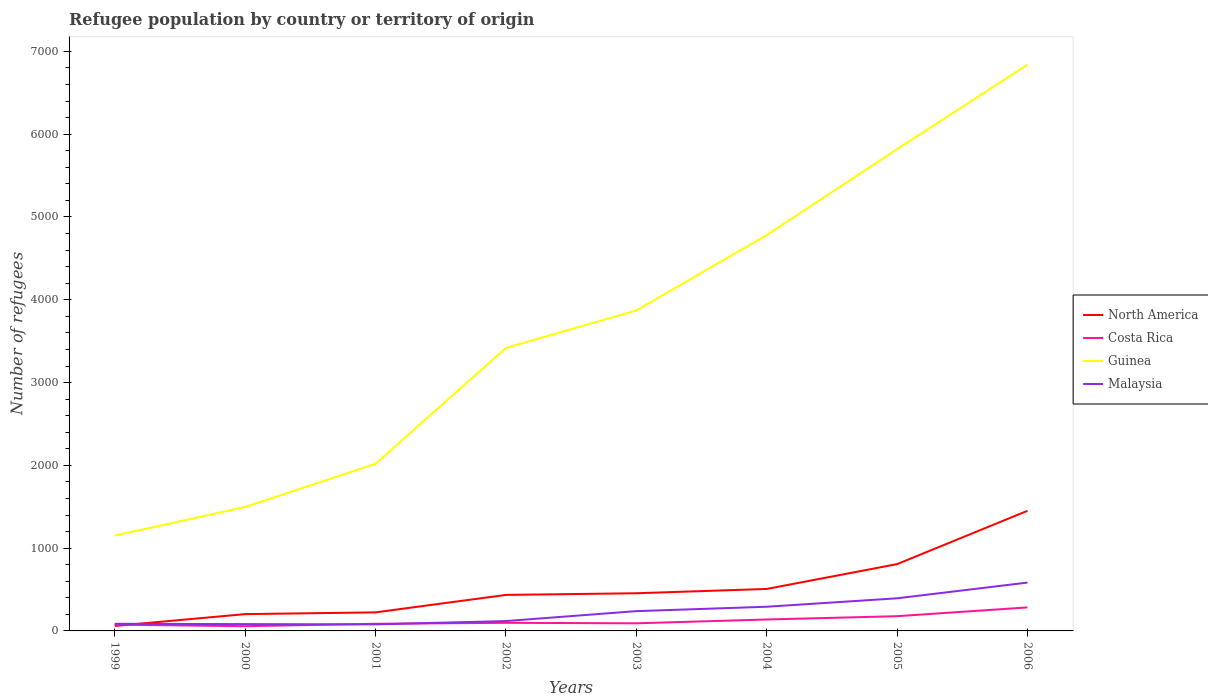How many different coloured lines are there?
Make the answer very short. 4. Does the line corresponding to Guinea intersect with the line corresponding to Costa Rica?
Provide a succinct answer. No. Across all years, what is the maximum number of refugees in Malaysia?
Provide a short and direct response. 79. In which year was the number of refugees in North America maximum?
Make the answer very short. 1999. What is the total number of refugees in Guinea in the graph?
Provide a succinct answer. -3285. What is the difference between the highest and the second highest number of refugees in Costa Rica?
Provide a short and direct response. 227. Is the number of refugees in Malaysia strictly greater than the number of refugees in Costa Rica over the years?
Provide a succinct answer. No. How many lines are there?
Provide a short and direct response. 4. How many years are there in the graph?
Make the answer very short. 8. What is the difference between two consecutive major ticks on the Y-axis?
Offer a terse response. 1000. Does the graph contain grids?
Offer a terse response. No. How are the legend labels stacked?
Make the answer very short. Vertical. What is the title of the graph?
Make the answer very short. Refugee population by country or territory of origin. Does "Monaco" appear as one of the legend labels in the graph?
Make the answer very short. No. What is the label or title of the X-axis?
Give a very brief answer. Years. What is the label or title of the Y-axis?
Offer a terse response. Number of refugees. What is the Number of refugees of North America in 1999?
Offer a terse response. 60. What is the Number of refugees in Costa Rica in 1999?
Ensure brevity in your answer.  76. What is the Number of refugees in Guinea in 1999?
Provide a succinct answer. 1151. What is the Number of refugees in Malaysia in 1999?
Ensure brevity in your answer.  86. What is the Number of refugees of North America in 2000?
Your response must be concise. 203. What is the Number of refugees of Costa Rica in 2000?
Make the answer very short. 57. What is the Number of refugees in Guinea in 2000?
Your answer should be very brief. 1497. What is the Number of refugees of North America in 2001?
Your answer should be very brief. 224. What is the Number of refugees of Costa Rica in 2001?
Provide a succinct answer. 86. What is the Number of refugees in Guinea in 2001?
Make the answer very short. 2019. What is the Number of refugees in Malaysia in 2001?
Ensure brevity in your answer.  79. What is the Number of refugees of North America in 2002?
Your response must be concise. 435. What is the Number of refugees in Guinea in 2002?
Your response must be concise. 3418. What is the Number of refugees of Malaysia in 2002?
Your answer should be very brief. 119. What is the Number of refugees of North America in 2003?
Your answer should be very brief. 455. What is the Number of refugees in Costa Rica in 2003?
Keep it short and to the point. 92. What is the Number of refugees of Guinea in 2003?
Make the answer very short. 3871. What is the Number of refugees in Malaysia in 2003?
Keep it short and to the point. 239. What is the Number of refugees in North America in 2004?
Your answer should be compact. 507. What is the Number of refugees in Costa Rica in 2004?
Your response must be concise. 138. What is the Number of refugees in Guinea in 2004?
Your answer should be very brief. 4782. What is the Number of refugees of Malaysia in 2004?
Your answer should be compact. 292. What is the Number of refugees of North America in 2005?
Make the answer very short. 807. What is the Number of refugees in Costa Rica in 2005?
Make the answer very short. 178. What is the Number of refugees of Guinea in 2005?
Offer a terse response. 5820. What is the Number of refugees of Malaysia in 2005?
Give a very brief answer. 394. What is the Number of refugees in North America in 2006?
Keep it short and to the point. 1451. What is the Number of refugees of Costa Rica in 2006?
Offer a very short reply. 284. What is the Number of refugees in Guinea in 2006?
Keep it short and to the point. 6840. What is the Number of refugees of Malaysia in 2006?
Give a very brief answer. 584. Across all years, what is the maximum Number of refugees in North America?
Offer a very short reply. 1451. Across all years, what is the maximum Number of refugees of Costa Rica?
Keep it short and to the point. 284. Across all years, what is the maximum Number of refugees in Guinea?
Provide a succinct answer. 6840. Across all years, what is the maximum Number of refugees of Malaysia?
Ensure brevity in your answer.  584. Across all years, what is the minimum Number of refugees in North America?
Your answer should be very brief. 60. Across all years, what is the minimum Number of refugees in Costa Rica?
Your answer should be compact. 57. Across all years, what is the minimum Number of refugees in Guinea?
Offer a very short reply. 1151. Across all years, what is the minimum Number of refugees of Malaysia?
Offer a terse response. 79. What is the total Number of refugees of North America in the graph?
Your response must be concise. 4142. What is the total Number of refugees in Costa Rica in the graph?
Your answer should be compact. 1009. What is the total Number of refugees of Guinea in the graph?
Your answer should be compact. 2.94e+04. What is the total Number of refugees of Malaysia in the graph?
Provide a succinct answer. 1875. What is the difference between the Number of refugees in North America in 1999 and that in 2000?
Your answer should be very brief. -143. What is the difference between the Number of refugees in Costa Rica in 1999 and that in 2000?
Make the answer very short. 19. What is the difference between the Number of refugees in Guinea in 1999 and that in 2000?
Provide a short and direct response. -346. What is the difference between the Number of refugees of Malaysia in 1999 and that in 2000?
Ensure brevity in your answer.  4. What is the difference between the Number of refugees in North America in 1999 and that in 2001?
Keep it short and to the point. -164. What is the difference between the Number of refugees in Costa Rica in 1999 and that in 2001?
Your answer should be compact. -10. What is the difference between the Number of refugees of Guinea in 1999 and that in 2001?
Your response must be concise. -868. What is the difference between the Number of refugees of Malaysia in 1999 and that in 2001?
Ensure brevity in your answer.  7. What is the difference between the Number of refugees of North America in 1999 and that in 2002?
Provide a short and direct response. -375. What is the difference between the Number of refugees in Guinea in 1999 and that in 2002?
Your response must be concise. -2267. What is the difference between the Number of refugees in Malaysia in 1999 and that in 2002?
Make the answer very short. -33. What is the difference between the Number of refugees in North America in 1999 and that in 2003?
Your answer should be compact. -395. What is the difference between the Number of refugees in Guinea in 1999 and that in 2003?
Give a very brief answer. -2720. What is the difference between the Number of refugees of Malaysia in 1999 and that in 2003?
Your response must be concise. -153. What is the difference between the Number of refugees in North America in 1999 and that in 2004?
Your answer should be very brief. -447. What is the difference between the Number of refugees in Costa Rica in 1999 and that in 2004?
Your answer should be compact. -62. What is the difference between the Number of refugees of Guinea in 1999 and that in 2004?
Provide a short and direct response. -3631. What is the difference between the Number of refugees in Malaysia in 1999 and that in 2004?
Your response must be concise. -206. What is the difference between the Number of refugees in North America in 1999 and that in 2005?
Provide a short and direct response. -747. What is the difference between the Number of refugees of Costa Rica in 1999 and that in 2005?
Give a very brief answer. -102. What is the difference between the Number of refugees in Guinea in 1999 and that in 2005?
Offer a terse response. -4669. What is the difference between the Number of refugees in Malaysia in 1999 and that in 2005?
Offer a very short reply. -308. What is the difference between the Number of refugees of North America in 1999 and that in 2006?
Give a very brief answer. -1391. What is the difference between the Number of refugees of Costa Rica in 1999 and that in 2006?
Your answer should be very brief. -208. What is the difference between the Number of refugees in Guinea in 1999 and that in 2006?
Offer a terse response. -5689. What is the difference between the Number of refugees in Malaysia in 1999 and that in 2006?
Offer a terse response. -498. What is the difference between the Number of refugees in Guinea in 2000 and that in 2001?
Ensure brevity in your answer.  -522. What is the difference between the Number of refugees of Malaysia in 2000 and that in 2001?
Offer a very short reply. 3. What is the difference between the Number of refugees in North America in 2000 and that in 2002?
Ensure brevity in your answer.  -232. What is the difference between the Number of refugees in Costa Rica in 2000 and that in 2002?
Your answer should be very brief. -41. What is the difference between the Number of refugees in Guinea in 2000 and that in 2002?
Provide a succinct answer. -1921. What is the difference between the Number of refugees of Malaysia in 2000 and that in 2002?
Offer a terse response. -37. What is the difference between the Number of refugees in North America in 2000 and that in 2003?
Your answer should be very brief. -252. What is the difference between the Number of refugees in Costa Rica in 2000 and that in 2003?
Your response must be concise. -35. What is the difference between the Number of refugees in Guinea in 2000 and that in 2003?
Provide a succinct answer. -2374. What is the difference between the Number of refugees in Malaysia in 2000 and that in 2003?
Give a very brief answer. -157. What is the difference between the Number of refugees of North America in 2000 and that in 2004?
Your answer should be compact. -304. What is the difference between the Number of refugees in Costa Rica in 2000 and that in 2004?
Provide a succinct answer. -81. What is the difference between the Number of refugees of Guinea in 2000 and that in 2004?
Keep it short and to the point. -3285. What is the difference between the Number of refugees in Malaysia in 2000 and that in 2004?
Provide a succinct answer. -210. What is the difference between the Number of refugees of North America in 2000 and that in 2005?
Provide a succinct answer. -604. What is the difference between the Number of refugees in Costa Rica in 2000 and that in 2005?
Make the answer very short. -121. What is the difference between the Number of refugees in Guinea in 2000 and that in 2005?
Your response must be concise. -4323. What is the difference between the Number of refugees in Malaysia in 2000 and that in 2005?
Provide a succinct answer. -312. What is the difference between the Number of refugees in North America in 2000 and that in 2006?
Your response must be concise. -1248. What is the difference between the Number of refugees of Costa Rica in 2000 and that in 2006?
Your answer should be very brief. -227. What is the difference between the Number of refugees in Guinea in 2000 and that in 2006?
Make the answer very short. -5343. What is the difference between the Number of refugees of Malaysia in 2000 and that in 2006?
Your answer should be compact. -502. What is the difference between the Number of refugees in North America in 2001 and that in 2002?
Give a very brief answer. -211. What is the difference between the Number of refugees of Guinea in 2001 and that in 2002?
Your answer should be very brief. -1399. What is the difference between the Number of refugees of North America in 2001 and that in 2003?
Give a very brief answer. -231. What is the difference between the Number of refugees in Guinea in 2001 and that in 2003?
Ensure brevity in your answer.  -1852. What is the difference between the Number of refugees in Malaysia in 2001 and that in 2003?
Keep it short and to the point. -160. What is the difference between the Number of refugees in North America in 2001 and that in 2004?
Offer a terse response. -283. What is the difference between the Number of refugees of Costa Rica in 2001 and that in 2004?
Keep it short and to the point. -52. What is the difference between the Number of refugees in Guinea in 2001 and that in 2004?
Give a very brief answer. -2763. What is the difference between the Number of refugees in Malaysia in 2001 and that in 2004?
Your response must be concise. -213. What is the difference between the Number of refugees of North America in 2001 and that in 2005?
Your response must be concise. -583. What is the difference between the Number of refugees of Costa Rica in 2001 and that in 2005?
Offer a very short reply. -92. What is the difference between the Number of refugees in Guinea in 2001 and that in 2005?
Your answer should be compact. -3801. What is the difference between the Number of refugees of Malaysia in 2001 and that in 2005?
Ensure brevity in your answer.  -315. What is the difference between the Number of refugees of North America in 2001 and that in 2006?
Provide a succinct answer. -1227. What is the difference between the Number of refugees in Costa Rica in 2001 and that in 2006?
Give a very brief answer. -198. What is the difference between the Number of refugees of Guinea in 2001 and that in 2006?
Provide a short and direct response. -4821. What is the difference between the Number of refugees in Malaysia in 2001 and that in 2006?
Your response must be concise. -505. What is the difference between the Number of refugees in Guinea in 2002 and that in 2003?
Provide a short and direct response. -453. What is the difference between the Number of refugees of Malaysia in 2002 and that in 2003?
Your answer should be compact. -120. What is the difference between the Number of refugees of North America in 2002 and that in 2004?
Give a very brief answer. -72. What is the difference between the Number of refugees in Costa Rica in 2002 and that in 2004?
Offer a very short reply. -40. What is the difference between the Number of refugees of Guinea in 2002 and that in 2004?
Give a very brief answer. -1364. What is the difference between the Number of refugees in Malaysia in 2002 and that in 2004?
Provide a succinct answer. -173. What is the difference between the Number of refugees in North America in 2002 and that in 2005?
Provide a succinct answer. -372. What is the difference between the Number of refugees of Costa Rica in 2002 and that in 2005?
Provide a succinct answer. -80. What is the difference between the Number of refugees of Guinea in 2002 and that in 2005?
Offer a very short reply. -2402. What is the difference between the Number of refugees of Malaysia in 2002 and that in 2005?
Give a very brief answer. -275. What is the difference between the Number of refugees in North America in 2002 and that in 2006?
Offer a very short reply. -1016. What is the difference between the Number of refugees in Costa Rica in 2002 and that in 2006?
Offer a terse response. -186. What is the difference between the Number of refugees in Guinea in 2002 and that in 2006?
Offer a terse response. -3422. What is the difference between the Number of refugees in Malaysia in 2002 and that in 2006?
Your answer should be very brief. -465. What is the difference between the Number of refugees in North America in 2003 and that in 2004?
Provide a succinct answer. -52. What is the difference between the Number of refugees of Costa Rica in 2003 and that in 2004?
Make the answer very short. -46. What is the difference between the Number of refugees of Guinea in 2003 and that in 2004?
Offer a very short reply. -911. What is the difference between the Number of refugees in Malaysia in 2003 and that in 2004?
Ensure brevity in your answer.  -53. What is the difference between the Number of refugees in North America in 2003 and that in 2005?
Ensure brevity in your answer.  -352. What is the difference between the Number of refugees in Costa Rica in 2003 and that in 2005?
Provide a short and direct response. -86. What is the difference between the Number of refugees in Guinea in 2003 and that in 2005?
Your answer should be compact. -1949. What is the difference between the Number of refugees in Malaysia in 2003 and that in 2005?
Provide a succinct answer. -155. What is the difference between the Number of refugees in North America in 2003 and that in 2006?
Make the answer very short. -996. What is the difference between the Number of refugees of Costa Rica in 2003 and that in 2006?
Keep it short and to the point. -192. What is the difference between the Number of refugees of Guinea in 2003 and that in 2006?
Keep it short and to the point. -2969. What is the difference between the Number of refugees in Malaysia in 2003 and that in 2006?
Give a very brief answer. -345. What is the difference between the Number of refugees of North America in 2004 and that in 2005?
Ensure brevity in your answer.  -300. What is the difference between the Number of refugees of Costa Rica in 2004 and that in 2005?
Ensure brevity in your answer.  -40. What is the difference between the Number of refugees of Guinea in 2004 and that in 2005?
Keep it short and to the point. -1038. What is the difference between the Number of refugees of Malaysia in 2004 and that in 2005?
Provide a succinct answer. -102. What is the difference between the Number of refugees in North America in 2004 and that in 2006?
Provide a short and direct response. -944. What is the difference between the Number of refugees of Costa Rica in 2004 and that in 2006?
Ensure brevity in your answer.  -146. What is the difference between the Number of refugees of Guinea in 2004 and that in 2006?
Keep it short and to the point. -2058. What is the difference between the Number of refugees of Malaysia in 2004 and that in 2006?
Your answer should be compact. -292. What is the difference between the Number of refugees of North America in 2005 and that in 2006?
Your answer should be compact. -644. What is the difference between the Number of refugees of Costa Rica in 2005 and that in 2006?
Keep it short and to the point. -106. What is the difference between the Number of refugees of Guinea in 2005 and that in 2006?
Give a very brief answer. -1020. What is the difference between the Number of refugees in Malaysia in 2005 and that in 2006?
Your answer should be compact. -190. What is the difference between the Number of refugees of North America in 1999 and the Number of refugees of Costa Rica in 2000?
Your answer should be very brief. 3. What is the difference between the Number of refugees of North America in 1999 and the Number of refugees of Guinea in 2000?
Give a very brief answer. -1437. What is the difference between the Number of refugees in Costa Rica in 1999 and the Number of refugees in Guinea in 2000?
Your answer should be very brief. -1421. What is the difference between the Number of refugees in Guinea in 1999 and the Number of refugees in Malaysia in 2000?
Your answer should be compact. 1069. What is the difference between the Number of refugees of North America in 1999 and the Number of refugees of Costa Rica in 2001?
Your response must be concise. -26. What is the difference between the Number of refugees in North America in 1999 and the Number of refugees in Guinea in 2001?
Provide a short and direct response. -1959. What is the difference between the Number of refugees in North America in 1999 and the Number of refugees in Malaysia in 2001?
Offer a terse response. -19. What is the difference between the Number of refugees in Costa Rica in 1999 and the Number of refugees in Guinea in 2001?
Keep it short and to the point. -1943. What is the difference between the Number of refugees of Guinea in 1999 and the Number of refugees of Malaysia in 2001?
Offer a terse response. 1072. What is the difference between the Number of refugees of North America in 1999 and the Number of refugees of Costa Rica in 2002?
Ensure brevity in your answer.  -38. What is the difference between the Number of refugees of North America in 1999 and the Number of refugees of Guinea in 2002?
Your answer should be compact. -3358. What is the difference between the Number of refugees in North America in 1999 and the Number of refugees in Malaysia in 2002?
Make the answer very short. -59. What is the difference between the Number of refugees of Costa Rica in 1999 and the Number of refugees of Guinea in 2002?
Ensure brevity in your answer.  -3342. What is the difference between the Number of refugees in Costa Rica in 1999 and the Number of refugees in Malaysia in 2002?
Provide a succinct answer. -43. What is the difference between the Number of refugees of Guinea in 1999 and the Number of refugees of Malaysia in 2002?
Give a very brief answer. 1032. What is the difference between the Number of refugees in North America in 1999 and the Number of refugees in Costa Rica in 2003?
Your response must be concise. -32. What is the difference between the Number of refugees in North America in 1999 and the Number of refugees in Guinea in 2003?
Keep it short and to the point. -3811. What is the difference between the Number of refugees of North America in 1999 and the Number of refugees of Malaysia in 2003?
Your answer should be very brief. -179. What is the difference between the Number of refugees in Costa Rica in 1999 and the Number of refugees in Guinea in 2003?
Provide a succinct answer. -3795. What is the difference between the Number of refugees of Costa Rica in 1999 and the Number of refugees of Malaysia in 2003?
Ensure brevity in your answer.  -163. What is the difference between the Number of refugees in Guinea in 1999 and the Number of refugees in Malaysia in 2003?
Ensure brevity in your answer.  912. What is the difference between the Number of refugees of North America in 1999 and the Number of refugees of Costa Rica in 2004?
Provide a short and direct response. -78. What is the difference between the Number of refugees of North America in 1999 and the Number of refugees of Guinea in 2004?
Your answer should be compact. -4722. What is the difference between the Number of refugees of North America in 1999 and the Number of refugees of Malaysia in 2004?
Offer a very short reply. -232. What is the difference between the Number of refugees in Costa Rica in 1999 and the Number of refugees in Guinea in 2004?
Make the answer very short. -4706. What is the difference between the Number of refugees of Costa Rica in 1999 and the Number of refugees of Malaysia in 2004?
Your answer should be compact. -216. What is the difference between the Number of refugees in Guinea in 1999 and the Number of refugees in Malaysia in 2004?
Your answer should be very brief. 859. What is the difference between the Number of refugees of North America in 1999 and the Number of refugees of Costa Rica in 2005?
Your answer should be very brief. -118. What is the difference between the Number of refugees in North America in 1999 and the Number of refugees in Guinea in 2005?
Provide a short and direct response. -5760. What is the difference between the Number of refugees in North America in 1999 and the Number of refugees in Malaysia in 2005?
Make the answer very short. -334. What is the difference between the Number of refugees in Costa Rica in 1999 and the Number of refugees in Guinea in 2005?
Provide a succinct answer. -5744. What is the difference between the Number of refugees of Costa Rica in 1999 and the Number of refugees of Malaysia in 2005?
Keep it short and to the point. -318. What is the difference between the Number of refugees in Guinea in 1999 and the Number of refugees in Malaysia in 2005?
Provide a succinct answer. 757. What is the difference between the Number of refugees of North America in 1999 and the Number of refugees of Costa Rica in 2006?
Your response must be concise. -224. What is the difference between the Number of refugees of North America in 1999 and the Number of refugees of Guinea in 2006?
Offer a very short reply. -6780. What is the difference between the Number of refugees of North America in 1999 and the Number of refugees of Malaysia in 2006?
Ensure brevity in your answer.  -524. What is the difference between the Number of refugees of Costa Rica in 1999 and the Number of refugees of Guinea in 2006?
Provide a short and direct response. -6764. What is the difference between the Number of refugees in Costa Rica in 1999 and the Number of refugees in Malaysia in 2006?
Provide a succinct answer. -508. What is the difference between the Number of refugees in Guinea in 1999 and the Number of refugees in Malaysia in 2006?
Offer a very short reply. 567. What is the difference between the Number of refugees in North America in 2000 and the Number of refugees in Costa Rica in 2001?
Your answer should be compact. 117. What is the difference between the Number of refugees of North America in 2000 and the Number of refugees of Guinea in 2001?
Ensure brevity in your answer.  -1816. What is the difference between the Number of refugees of North America in 2000 and the Number of refugees of Malaysia in 2001?
Your answer should be compact. 124. What is the difference between the Number of refugees of Costa Rica in 2000 and the Number of refugees of Guinea in 2001?
Give a very brief answer. -1962. What is the difference between the Number of refugees in Guinea in 2000 and the Number of refugees in Malaysia in 2001?
Your response must be concise. 1418. What is the difference between the Number of refugees in North America in 2000 and the Number of refugees in Costa Rica in 2002?
Offer a terse response. 105. What is the difference between the Number of refugees of North America in 2000 and the Number of refugees of Guinea in 2002?
Your response must be concise. -3215. What is the difference between the Number of refugees of North America in 2000 and the Number of refugees of Malaysia in 2002?
Offer a terse response. 84. What is the difference between the Number of refugees of Costa Rica in 2000 and the Number of refugees of Guinea in 2002?
Your response must be concise. -3361. What is the difference between the Number of refugees in Costa Rica in 2000 and the Number of refugees in Malaysia in 2002?
Offer a very short reply. -62. What is the difference between the Number of refugees in Guinea in 2000 and the Number of refugees in Malaysia in 2002?
Offer a very short reply. 1378. What is the difference between the Number of refugees of North America in 2000 and the Number of refugees of Costa Rica in 2003?
Your answer should be very brief. 111. What is the difference between the Number of refugees in North America in 2000 and the Number of refugees in Guinea in 2003?
Provide a succinct answer. -3668. What is the difference between the Number of refugees of North America in 2000 and the Number of refugees of Malaysia in 2003?
Provide a succinct answer. -36. What is the difference between the Number of refugees in Costa Rica in 2000 and the Number of refugees in Guinea in 2003?
Your answer should be compact. -3814. What is the difference between the Number of refugees of Costa Rica in 2000 and the Number of refugees of Malaysia in 2003?
Your answer should be very brief. -182. What is the difference between the Number of refugees of Guinea in 2000 and the Number of refugees of Malaysia in 2003?
Your response must be concise. 1258. What is the difference between the Number of refugees of North America in 2000 and the Number of refugees of Guinea in 2004?
Provide a short and direct response. -4579. What is the difference between the Number of refugees in North America in 2000 and the Number of refugees in Malaysia in 2004?
Your answer should be compact. -89. What is the difference between the Number of refugees of Costa Rica in 2000 and the Number of refugees of Guinea in 2004?
Your response must be concise. -4725. What is the difference between the Number of refugees in Costa Rica in 2000 and the Number of refugees in Malaysia in 2004?
Keep it short and to the point. -235. What is the difference between the Number of refugees of Guinea in 2000 and the Number of refugees of Malaysia in 2004?
Your answer should be compact. 1205. What is the difference between the Number of refugees in North America in 2000 and the Number of refugees in Guinea in 2005?
Your response must be concise. -5617. What is the difference between the Number of refugees of North America in 2000 and the Number of refugees of Malaysia in 2005?
Offer a terse response. -191. What is the difference between the Number of refugees in Costa Rica in 2000 and the Number of refugees in Guinea in 2005?
Your answer should be compact. -5763. What is the difference between the Number of refugees in Costa Rica in 2000 and the Number of refugees in Malaysia in 2005?
Provide a succinct answer. -337. What is the difference between the Number of refugees in Guinea in 2000 and the Number of refugees in Malaysia in 2005?
Provide a short and direct response. 1103. What is the difference between the Number of refugees of North America in 2000 and the Number of refugees of Costa Rica in 2006?
Your answer should be compact. -81. What is the difference between the Number of refugees in North America in 2000 and the Number of refugees in Guinea in 2006?
Your answer should be compact. -6637. What is the difference between the Number of refugees in North America in 2000 and the Number of refugees in Malaysia in 2006?
Provide a succinct answer. -381. What is the difference between the Number of refugees in Costa Rica in 2000 and the Number of refugees in Guinea in 2006?
Your answer should be compact. -6783. What is the difference between the Number of refugees of Costa Rica in 2000 and the Number of refugees of Malaysia in 2006?
Provide a short and direct response. -527. What is the difference between the Number of refugees of Guinea in 2000 and the Number of refugees of Malaysia in 2006?
Provide a succinct answer. 913. What is the difference between the Number of refugees in North America in 2001 and the Number of refugees in Costa Rica in 2002?
Make the answer very short. 126. What is the difference between the Number of refugees in North America in 2001 and the Number of refugees in Guinea in 2002?
Your response must be concise. -3194. What is the difference between the Number of refugees of North America in 2001 and the Number of refugees of Malaysia in 2002?
Keep it short and to the point. 105. What is the difference between the Number of refugees in Costa Rica in 2001 and the Number of refugees in Guinea in 2002?
Offer a very short reply. -3332. What is the difference between the Number of refugees of Costa Rica in 2001 and the Number of refugees of Malaysia in 2002?
Make the answer very short. -33. What is the difference between the Number of refugees of Guinea in 2001 and the Number of refugees of Malaysia in 2002?
Keep it short and to the point. 1900. What is the difference between the Number of refugees of North America in 2001 and the Number of refugees of Costa Rica in 2003?
Your answer should be very brief. 132. What is the difference between the Number of refugees in North America in 2001 and the Number of refugees in Guinea in 2003?
Provide a succinct answer. -3647. What is the difference between the Number of refugees in North America in 2001 and the Number of refugees in Malaysia in 2003?
Keep it short and to the point. -15. What is the difference between the Number of refugees in Costa Rica in 2001 and the Number of refugees in Guinea in 2003?
Provide a short and direct response. -3785. What is the difference between the Number of refugees of Costa Rica in 2001 and the Number of refugees of Malaysia in 2003?
Provide a succinct answer. -153. What is the difference between the Number of refugees in Guinea in 2001 and the Number of refugees in Malaysia in 2003?
Give a very brief answer. 1780. What is the difference between the Number of refugees of North America in 2001 and the Number of refugees of Guinea in 2004?
Offer a terse response. -4558. What is the difference between the Number of refugees of North America in 2001 and the Number of refugees of Malaysia in 2004?
Provide a succinct answer. -68. What is the difference between the Number of refugees of Costa Rica in 2001 and the Number of refugees of Guinea in 2004?
Offer a terse response. -4696. What is the difference between the Number of refugees in Costa Rica in 2001 and the Number of refugees in Malaysia in 2004?
Make the answer very short. -206. What is the difference between the Number of refugees of Guinea in 2001 and the Number of refugees of Malaysia in 2004?
Give a very brief answer. 1727. What is the difference between the Number of refugees in North America in 2001 and the Number of refugees in Costa Rica in 2005?
Your answer should be compact. 46. What is the difference between the Number of refugees in North America in 2001 and the Number of refugees in Guinea in 2005?
Ensure brevity in your answer.  -5596. What is the difference between the Number of refugees in North America in 2001 and the Number of refugees in Malaysia in 2005?
Keep it short and to the point. -170. What is the difference between the Number of refugees of Costa Rica in 2001 and the Number of refugees of Guinea in 2005?
Your response must be concise. -5734. What is the difference between the Number of refugees in Costa Rica in 2001 and the Number of refugees in Malaysia in 2005?
Your response must be concise. -308. What is the difference between the Number of refugees in Guinea in 2001 and the Number of refugees in Malaysia in 2005?
Give a very brief answer. 1625. What is the difference between the Number of refugees in North America in 2001 and the Number of refugees in Costa Rica in 2006?
Your answer should be compact. -60. What is the difference between the Number of refugees in North America in 2001 and the Number of refugees in Guinea in 2006?
Provide a succinct answer. -6616. What is the difference between the Number of refugees of North America in 2001 and the Number of refugees of Malaysia in 2006?
Your answer should be very brief. -360. What is the difference between the Number of refugees in Costa Rica in 2001 and the Number of refugees in Guinea in 2006?
Provide a succinct answer. -6754. What is the difference between the Number of refugees in Costa Rica in 2001 and the Number of refugees in Malaysia in 2006?
Make the answer very short. -498. What is the difference between the Number of refugees of Guinea in 2001 and the Number of refugees of Malaysia in 2006?
Offer a very short reply. 1435. What is the difference between the Number of refugees of North America in 2002 and the Number of refugees of Costa Rica in 2003?
Your response must be concise. 343. What is the difference between the Number of refugees in North America in 2002 and the Number of refugees in Guinea in 2003?
Your answer should be very brief. -3436. What is the difference between the Number of refugees in North America in 2002 and the Number of refugees in Malaysia in 2003?
Your answer should be very brief. 196. What is the difference between the Number of refugees in Costa Rica in 2002 and the Number of refugees in Guinea in 2003?
Provide a short and direct response. -3773. What is the difference between the Number of refugees of Costa Rica in 2002 and the Number of refugees of Malaysia in 2003?
Your answer should be very brief. -141. What is the difference between the Number of refugees of Guinea in 2002 and the Number of refugees of Malaysia in 2003?
Make the answer very short. 3179. What is the difference between the Number of refugees of North America in 2002 and the Number of refugees of Costa Rica in 2004?
Ensure brevity in your answer.  297. What is the difference between the Number of refugees in North America in 2002 and the Number of refugees in Guinea in 2004?
Your answer should be very brief. -4347. What is the difference between the Number of refugees in North America in 2002 and the Number of refugees in Malaysia in 2004?
Your response must be concise. 143. What is the difference between the Number of refugees in Costa Rica in 2002 and the Number of refugees in Guinea in 2004?
Provide a succinct answer. -4684. What is the difference between the Number of refugees in Costa Rica in 2002 and the Number of refugees in Malaysia in 2004?
Offer a terse response. -194. What is the difference between the Number of refugees of Guinea in 2002 and the Number of refugees of Malaysia in 2004?
Your response must be concise. 3126. What is the difference between the Number of refugees in North America in 2002 and the Number of refugees in Costa Rica in 2005?
Your answer should be compact. 257. What is the difference between the Number of refugees in North America in 2002 and the Number of refugees in Guinea in 2005?
Offer a very short reply. -5385. What is the difference between the Number of refugees in North America in 2002 and the Number of refugees in Malaysia in 2005?
Provide a short and direct response. 41. What is the difference between the Number of refugees in Costa Rica in 2002 and the Number of refugees in Guinea in 2005?
Offer a very short reply. -5722. What is the difference between the Number of refugees of Costa Rica in 2002 and the Number of refugees of Malaysia in 2005?
Make the answer very short. -296. What is the difference between the Number of refugees of Guinea in 2002 and the Number of refugees of Malaysia in 2005?
Ensure brevity in your answer.  3024. What is the difference between the Number of refugees of North America in 2002 and the Number of refugees of Costa Rica in 2006?
Provide a short and direct response. 151. What is the difference between the Number of refugees of North America in 2002 and the Number of refugees of Guinea in 2006?
Your answer should be very brief. -6405. What is the difference between the Number of refugees in North America in 2002 and the Number of refugees in Malaysia in 2006?
Keep it short and to the point. -149. What is the difference between the Number of refugees in Costa Rica in 2002 and the Number of refugees in Guinea in 2006?
Offer a terse response. -6742. What is the difference between the Number of refugees in Costa Rica in 2002 and the Number of refugees in Malaysia in 2006?
Give a very brief answer. -486. What is the difference between the Number of refugees in Guinea in 2002 and the Number of refugees in Malaysia in 2006?
Ensure brevity in your answer.  2834. What is the difference between the Number of refugees of North America in 2003 and the Number of refugees of Costa Rica in 2004?
Your answer should be compact. 317. What is the difference between the Number of refugees in North America in 2003 and the Number of refugees in Guinea in 2004?
Keep it short and to the point. -4327. What is the difference between the Number of refugees in North America in 2003 and the Number of refugees in Malaysia in 2004?
Offer a very short reply. 163. What is the difference between the Number of refugees of Costa Rica in 2003 and the Number of refugees of Guinea in 2004?
Make the answer very short. -4690. What is the difference between the Number of refugees in Costa Rica in 2003 and the Number of refugees in Malaysia in 2004?
Your answer should be very brief. -200. What is the difference between the Number of refugees of Guinea in 2003 and the Number of refugees of Malaysia in 2004?
Give a very brief answer. 3579. What is the difference between the Number of refugees of North America in 2003 and the Number of refugees of Costa Rica in 2005?
Provide a short and direct response. 277. What is the difference between the Number of refugees of North America in 2003 and the Number of refugees of Guinea in 2005?
Keep it short and to the point. -5365. What is the difference between the Number of refugees in North America in 2003 and the Number of refugees in Malaysia in 2005?
Your response must be concise. 61. What is the difference between the Number of refugees in Costa Rica in 2003 and the Number of refugees in Guinea in 2005?
Your answer should be very brief. -5728. What is the difference between the Number of refugees of Costa Rica in 2003 and the Number of refugees of Malaysia in 2005?
Offer a very short reply. -302. What is the difference between the Number of refugees in Guinea in 2003 and the Number of refugees in Malaysia in 2005?
Keep it short and to the point. 3477. What is the difference between the Number of refugees in North America in 2003 and the Number of refugees in Costa Rica in 2006?
Your response must be concise. 171. What is the difference between the Number of refugees of North America in 2003 and the Number of refugees of Guinea in 2006?
Ensure brevity in your answer.  -6385. What is the difference between the Number of refugees of North America in 2003 and the Number of refugees of Malaysia in 2006?
Provide a short and direct response. -129. What is the difference between the Number of refugees of Costa Rica in 2003 and the Number of refugees of Guinea in 2006?
Offer a terse response. -6748. What is the difference between the Number of refugees of Costa Rica in 2003 and the Number of refugees of Malaysia in 2006?
Keep it short and to the point. -492. What is the difference between the Number of refugees of Guinea in 2003 and the Number of refugees of Malaysia in 2006?
Offer a very short reply. 3287. What is the difference between the Number of refugees in North America in 2004 and the Number of refugees in Costa Rica in 2005?
Make the answer very short. 329. What is the difference between the Number of refugees in North America in 2004 and the Number of refugees in Guinea in 2005?
Provide a succinct answer. -5313. What is the difference between the Number of refugees in North America in 2004 and the Number of refugees in Malaysia in 2005?
Keep it short and to the point. 113. What is the difference between the Number of refugees of Costa Rica in 2004 and the Number of refugees of Guinea in 2005?
Provide a succinct answer. -5682. What is the difference between the Number of refugees of Costa Rica in 2004 and the Number of refugees of Malaysia in 2005?
Ensure brevity in your answer.  -256. What is the difference between the Number of refugees of Guinea in 2004 and the Number of refugees of Malaysia in 2005?
Your answer should be compact. 4388. What is the difference between the Number of refugees in North America in 2004 and the Number of refugees in Costa Rica in 2006?
Offer a terse response. 223. What is the difference between the Number of refugees in North America in 2004 and the Number of refugees in Guinea in 2006?
Offer a terse response. -6333. What is the difference between the Number of refugees of North America in 2004 and the Number of refugees of Malaysia in 2006?
Offer a very short reply. -77. What is the difference between the Number of refugees of Costa Rica in 2004 and the Number of refugees of Guinea in 2006?
Make the answer very short. -6702. What is the difference between the Number of refugees of Costa Rica in 2004 and the Number of refugees of Malaysia in 2006?
Offer a terse response. -446. What is the difference between the Number of refugees in Guinea in 2004 and the Number of refugees in Malaysia in 2006?
Ensure brevity in your answer.  4198. What is the difference between the Number of refugees of North America in 2005 and the Number of refugees of Costa Rica in 2006?
Your answer should be compact. 523. What is the difference between the Number of refugees in North America in 2005 and the Number of refugees in Guinea in 2006?
Provide a succinct answer. -6033. What is the difference between the Number of refugees in North America in 2005 and the Number of refugees in Malaysia in 2006?
Provide a succinct answer. 223. What is the difference between the Number of refugees of Costa Rica in 2005 and the Number of refugees of Guinea in 2006?
Your answer should be very brief. -6662. What is the difference between the Number of refugees in Costa Rica in 2005 and the Number of refugees in Malaysia in 2006?
Offer a very short reply. -406. What is the difference between the Number of refugees in Guinea in 2005 and the Number of refugees in Malaysia in 2006?
Offer a very short reply. 5236. What is the average Number of refugees in North America per year?
Keep it short and to the point. 517.75. What is the average Number of refugees in Costa Rica per year?
Your response must be concise. 126.12. What is the average Number of refugees of Guinea per year?
Ensure brevity in your answer.  3674.75. What is the average Number of refugees of Malaysia per year?
Ensure brevity in your answer.  234.38. In the year 1999, what is the difference between the Number of refugees in North America and Number of refugees in Guinea?
Ensure brevity in your answer.  -1091. In the year 1999, what is the difference between the Number of refugees in Costa Rica and Number of refugees in Guinea?
Keep it short and to the point. -1075. In the year 1999, what is the difference between the Number of refugees of Costa Rica and Number of refugees of Malaysia?
Provide a succinct answer. -10. In the year 1999, what is the difference between the Number of refugees in Guinea and Number of refugees in Malaysia?
Offer a terse response. 1065. In the year 2000, what is the difference between the Number of refugees of North America and Number of refugees of Costa Rica?
Offer a very short reply. 146. In the year 2000, what is the difference between the Number of refugees in North America and Number of refugees in Guinea?
Make the answer very short. -1294. In the year 2000, what is the difference between the Number of refugees of North America and Number of refugees of Malaysia?
Your answer should be compact. 121. In the year 2000, what is the difference between the Number of refugees of Costa Rica and Number of refugees of Guinea?
Your answer should be very brief. -1440. In the year 2000, what is the difference between the Number of refugees of Costa Rica and Number of refugees of Malaysia?
Provide a short and direct response. -25. In the year 2000, what is the difference between the Number of refugees of Guinea and Number of refugees of Malaysia?
Provide a short and direct response. 1415. In the year 2001, what is the difference between the Number of refugees of North America and Number of refugees of Costa Rica?
Your response must be concise. 138. In the year 2001, what is the difference between the Number of refugees in North America and Number of refugees in Guinea?
Your answer should be compact. -1795. In the year 2001, what is the difference between the Number of refugees of North America and Number of refugees of Malaysia?
Ensure brevity in your answer.  145. In the year 2001, what is the difference between the Number of refugees of Costa Rica and Number of refugees of Guinea?
Make the answer very short. -1933. In the year 2001, what is the difference between the Number of refugees in Guinea and Number of refugees in Malaysia?
Provide a short and direct response. 1940. In the year 2002, what is the difference between the Number of refugees of North America and Number of refugees of Costa Rica?
Keep it short and to the point. 337. In the year 2002, what is the difference between the Number of refugees of North America and Number of refugees of Guinea?
Your answer should be compact. -2983. In the year 2002, what is the difference between the Number of refugees of North America and Number of refugees of Malaysia?
Ensure brevity in your answer.  316. In the year 2002, what is the difference between the Number of refugees of Costa Rica and Number of refugees of Guinea?
Ensure brevity in your answer.  -3320. In the year 2002, what is the difference between the Number of refugees in Costa Rica and Number of refugees in Malaysia?
Give a very brief answer. -21. In the year 2002, what is the difference between the Number of refugees of Guinea and Number of refugees of Malaysia?
Your response must be concise. 3299. In the year 2003, what is the difference between the Number of refugees in North America and Number of refugees in Costa Rica?
Keep it short and to the point. 363. In the year 2003, what is the difference between the Number of refugees in North America and Number of refugees in Guinea?
Provide a succinct answer. -3416. In the year 2003, what is the difference between the Number of refugees in North America and Number of refugees in Malaysia?
Your answer should be very brief. 216. In the year 2003, what is the difference between the Number of refugees in Costa Rica and Number of refugees in Guinea?
Ensure brevity in your answer.  -3779. In the year 2003, what is the difference between the Number of refugees of Costa Rica and Number of refugees of Malaysia?
Your answer should be very brief. -147. In the year 2003, what is the difference between the Number of refugees of Guinea and Number of refugees of Malaysia?
Make the answer very short. 3632. In the year 2004, what is the difference between the Number of refugees of North America and Number of refugees of Costa Rica?
Make the answer very short. 369. In the year 2004, what is the difference between the Number of refugees in North America and Number of refugees in Guinea?
Ensure brevity in your answer.  -4275. In the year 2004, what is the difference between the Number of refugees of North America and Number of refugees of Malaysia?
Make the answer very short. 215. In the year 2004, what is the difference between the Number of refugees of Costa Rica and Number of refugees of Guinea?
Give a very brief answer. -4644. In the year 2004, what is the difference between the Number of refugees in Costa Rica and Number of refugees in Malaysia?
Give a very brief answer. -154. In the year 2004, what is the difference between the Number of refugees of Guinea and Number of refugees of Malaysia?
Your answer should be compact. 4490. In the year 2005, what is the difference between the Number of refugees of North America and Number of refugees of Costa Rica?
Make the answer very short. 629. In the year 2005, what is the difference between the Number of refugees in North America and Number of refugees in Guinea?
Ensure brevity in your answer.  -5013. In the year 2005, what is the difference between the Number of refugees of North America and Number of refugees of Malaysia?
Provide a short and direct response. 413. In the year 2005, what is the difference between the Number of refugees of Costa Rica and Number of refugees of Guinea?
Keep it short and to the point. -5642. In the year 2005, what is the difference between the Number of refugees of Costa Rica and Number of refugees of Malaysia?
Provide a short and direct response. -216. In the year 2005, what is the difference between the Number of refugees of Guinea and Number of refugees of Malaysia?
Offer a very short reply. 5426. In the year 2006, what is the difference between the Number of refugees in North America and Number of refugees in Costa Rica?
Offer a very short reply. 1167. In the year 2006, what is the difference between the Number of refugees of North America and Number of refugees of Guinea?
Offer a terse response. -5389. In the year 2006, what is the difference between the Number of refugees of North America and Number of refugees of Malaysia?
Your answer should be very brief. 867. In the year 2006, what is the difference between the Number of refugees of Costa Rica and Number of refugees of Guinea?
Give a very brief answer. -6556. In the year 2006, what is the difference between the Number of refugees of Costa Rica and Number of refugees of Malaysia?
Give a very brief answer. -300. In the year 2006, what is the difference between the Number of refugees in Guinea and Number of refugees in Malaysia?
Your response must be concise. 6256. What is the ratio of the Number of refugees in North America in 1999 to that in 2000?
Make the answer very short. 0.3. What is the ratio of the Number of refugees of Costa Rica in 1999 to that in 2000?
Provide a short and direct response. 1.33. What is the ratio of the Number of refugees in Guinea in 1999 to that in 2000?
Your response must be concise. 0.77. What is the ratio of the Number of refugees in Malaysia in 1999 to that in 2000?
Offer a very short reply. 1.05. What is the ratio of the Number of refugees of North America in 1999 to that in 2001?
Give a very brief answer. 0.27. What is the ratio of the Number of refugees of Costa Rica in 1999 to that in 2001?
Ensure brevity in your answer.  0.88. What is the ratio of the Number of refugees in Guinea in 1999 to that in 2001?
Offer a very short reply. 0.57. What is the ratio of the Number of refugees of Malaysia in 1999 to that in 2001?
Ensure brevity in your answer.  1.09. What is the ratio of the Number of refugees of North America in 1999 to that in 2002?
Your response must be concise. 0.14. What is the ratio of the Number of refugees of Costa Rica in 1999 to that in 2002?
Ensure brevity in your answer.  0.78. What is the ratio of the Number of refugees of Guinea in 1999 to that in 2002?
Your response must be concise. 0.34. What is the ratio of the Number of refugees in Malaysia in 1999 to that in 2002?
Your answer should be compact. 0.72. What is the ratio of the Number of refugees of North America in 1999 to that in 2003?
Your answer should be very brief. 0.13. What is the ratio of the Number of refugees in Costa Rica in 1999 to that in 2003?
Offer a terse response. 0.83. What is the ratio of the Number of refugees in Guinea in 1999 to that in 2003?
Keep it short and to the point. 0.3. What is the ratio of the Number of refugees of Malaysia in 1999 to that in 2003?
Provide a succinct answer. 0.36. What is the ratio of the Number of refugees in North America in 1999 to that in 2004?
Ensure brevity in your answer.  0.12. What is the ratio of the Number of refugees in Costa Rica in 1999 to that in 2004?
Your answer should be compact. 0.55. What is the ratio of the Number of refugees of Guinea in 1999 to that in 2004?
Keep it short and to the point. 0.24. What is the ratio of the Number of refugees in Malaysia in 1999 to that in 2004?
Provide a short and direct response. 0.29. What is the ratio of the Number of refugees of North America in 1999 to that in 2005?
Your answer should be compact. 0.07. What is the ratio of the Number of refugees of Costa Rica in 1999 to that in 2005?
Give a very brief answer. 0.43. What is the ratio of the Number of refugees of Guinea in 1999 to that in 2005?
Keep it short and to the point. 0.2. What is the ratio of the Number of refugees in Malaysia in 1999 to that in 2005?
Your response must be concise. 0.22. What is the ratio of the Number of refugees in North America in 1999 to that in 2006?
Provide a succinct answer. 0.04. What is the ratio of the Number of refugees of Costa Rica in 1999 to that in 2006?
Your response must be concise. 0.27. What is the ratio of the Number of refugees of Guinea in 1999 to that in 2006?
Keep it short and to the point. 0.17. What is the ratio of the Number of refugees in Malaysia in 1999 to that in 2006?
Provide a succinct answer. 0.15. What is the ratio of the Number of refugees of North America in 2000 to that in 2001?
Your answer should be compact. 0.91. What is the ratio of the Number of refugees of Costa Rica in 2000 to that in 2001?
Make the answer very short. 0.66. What is the ratio of the Number of refugees of Guinea in 2000 to that in 2001?
Ensure brevity in your answer.  0.74. What is the ratio of the Number of refugees of Malaysia in 2000 to that in 2001?
Make the answer very short. 1.04. What is the ratio of the Number of refugees of North America in 2000 to that in 2002?
Your response must be concise. 0.47. What is the ratio of the Number of refugees in Costa Rica in 2000 to that in 2002?
Your answer should be compact. 0.58. What is the ratio of the Number of refugees in Guinea in 2000 to that in 2002?
Provide a short and direct response. 0.44. What is the ratio of the Number of refugees of Malaysia in 2000 to that in 2002?
Make the answer very short. 0.69. What is the ratio of the Number of refugees in North America in 2000 to that in 2003?
Keep it short and to the point. 0.45. What is the ratio of the Number of refugees of Costa Rica in 2000 to that in 2003?
Provide a short and direct response. 0.62. What is the ratio of the Number of refugees of Guinea in 2000 to that in 2003?
Make the answer very short. 0.39. What is the ratio of the Number of refugees of Malaysia in 2000 to that in 2003?
Your answer should be compact. 0.34. What is the ratio of the Number of refugees of North America in 2000 to that in 2004?
Provide a short and direct response. 0.4. What is the ratio of the Number of refugees in Costa Rica in 2000 to that in 2004?
Provide a short and direct response. 0.41. What is the ratio of the Number of refugees of Guinea in 2000 to that in 2004?
Your response must be concise. 0.31. What is the ratio of the Number of refugees in Malaysia in 2000 to that in 2004?
Your response must be concise. 0.28. What is the ratio of the Number of refugees of North America in 2000 to that in 2005?
Provide a short and direct response. 0.25. What is the ratio of the Number of refugees in Costa Rica in 2000 to that in 2005?
Ensure brevity in your answer.  0.32. What is the ratio of the Number of refugees in Guinea in 2000 to that in 2005?
Provide a succinct answer. 0.26. What is the ratio of the Number of refugees in Malaysia in 2000 to that in 2005?
Give a very brief answer. 0.21. What is the ratio of the Number of refugees of North America in 2000 to that in 2006?
Keep it short and to the point. 0.14. What is the ratio of the Number of refugees of Costa Rica in 2000 to that in 2006?
Your answer should be compact. 0.2. What is the ratio of the Number of refugees in Guinea in 2000 to that in 2006?
Offer a very short reply. 0.22. What is the ratio of the Number of refugees in Malaysia in 2000 to that in 2006?
Offer a terse response. 0.14. What is the ratio of the Number of refugees in North America in 2001 to that in 2002?
Keep it short and to the point. 0.51. What is the ratio of the Number of refugees of Costa Rica in 2001 to that in 2002?
Provide a succinct answer. 0.88. What is the ratio of the Number of refugees in Guinea in 2001 to that in 2002?
Your response must be concise. 0.59. What is the ratio of the Number of refugees of Malaysia in 2001 to that in 2002?
Give a very brief answer. 0.66. What is the ratio of the Number of refugees of North America in 2001 to that in 2003?
Ensure brevity in your answer.  0.49. What is the ratio of the Number of refugees in Costa Rica in 2001 to that in 2003?
Offer a terse response. 0.93. What is the ratio of the Number of refugees in Guinea in 2001 to that in 2003?
Provide a succinct answer. 0.52. What is the ratio of the Number of refugees of Malaysia in 2001 to that in 2003?
Provide a short and direct response. 0.33. What is the ratio of the Number of refugees in North America in 2001 to that in 2004?
Offer a terse response. 0.44. What is the ratio of the Number of refugees in Costa Rica in 2001 to that in 2004?
Provide a short and direct response. 0.62. What is the ratio of the Number of refugees of Guinea in 2001 to that in 2004?
Your answer should be compact. 0.42. What is the ratio of the Number of refugees of Malaysia in 2001 to that in 2004?
Your answer should be very brief. 0.27. What is the ratio of the Number of refugees in North America in 2001 to that in 2005?
Give a very brief answer. 0.28. What is the ratio of the Number of refugees in Costa Rica in 2001 to that in 2005?
Provide a short and direct response. 0.48. What is the ratio of the Number of refugees of Guinea in 2001 to that in 2005?
Provide a succinct answer. 0.35. What is the ratio of the Number of refugees in Malaysia in 2001 to that in 2005?
Your response must be concise. 0.2. What is the ratio of the Number of refugees of North America in 2001 to that in 2006?
Offer a very short reply. 0.15. What is the ratio of the Number of refugees of Costa Rica in 2001 to that in 2006?
Your response must be concise. 0.3. What is the ratio of the Number of refugees of Guinea in 2001 to that in 2006?
Give a very brief answer. 0.3. What is the ratio of the Number of refugees in Malaysia in 2001 to that in 2006?
Make the answer very short. 0.14. What is the ratio of the Number of refugees of North America in 2002 to that in 2003?
Offer a terse response. 0.96. What is the ratio of the Number of refugees of Costa Rica in 2002 to that in 2003?
Ensure brevity in your answer.  1.07. What is the ratio of the Number of refugees of Guinea in 2002 to that in 2003?
Provide a short and direct response. 0.88. What is the ratio of the Number of refugees of Malaysia in 2002 to that in 2003?
Offer a terse response. 0.5. What is the ratio of the Number of refugees of North America in 2002 to that in 2004?
Keep it short and to the point. 0.86. What is the ratio of the Number of refugees of Costa Rica in 2002 to that in 2004?
Ensure brevity in your answer.  0.71. What is the ratio of the Number of refugees in Guinea in 2002 to that in 2004?
Ensure brevity in your answer.  0.71. What is the ratio of the Number of refugees of Malaysia in 2002 to that in 2004?
Your answer should be very brief. 0.41. What is the ratio of the Number of refugees in North America in 2002 to that in 2005?
Your answer should be very brief. 0.54. What is the ratio of the Number of refugees in Costa Rica in 2002 to that in 2005?
Offer a terse response. 0.55. What is the ratio of the Number of refugees of Guinea in 2002 to that in 2005?
Offer a very short reply. 0.59. What is the ratio of the Number of refugees in Malaysia in 2002 to that in 2005?
Provide a short and direct response. 0.3. What is the ratio of the Number of refugees in North America in 2002 to that in 2006?
Your answer should be compact. 0.3. What is the ratio of the Number of refugees in Costa Rica in 2002 to that in 2006?
Provide a short and direct response. 0.35. What is the ratio of the Number of refugees in Guinea in 2002 to that in 2006?
Your response must be concise. 0.5. What is the ratio of the Number of refugees of Malaysia in 2002 to that in 2006?
Your answer should be compact. 0.2. What is the ratio of the Number of refugees in North America in 2003 to that in 2004?
Offer a terse response. 0.9. What is the ratio of the Number of refugees in Costa Rica in 2003 to that in 2004?
Make the answer very short. 0.67. What is the ratio of the Number of refugees of Guinea in 2003 to that in 2004?
Provide a succinct answer. 0.81. What is the ratio of the Number of refugees of Malaysia in 2003 to that in 2004?
Your answer should be compact. 0.82. What is the ratio of the Number of refugees of North America in 2003 to that in 2005?
Your answer should be compact. 0.56. What is the ratio of the Number of refugees in Costa Rica in 2003 to that in 2005?
Ensure brevity in your answer.  0.52. What is the ratio of the Number of refugees of Guinea in 2003 to that in 2005?
Give a very brief answer. 0.67. What is the ratio of the Number of refugees in Malaysia in 2003 to that in 2005?
Offer a very short reply. 0.61. What is the ratio of the Number of refugees in North America in 2003 to that in 2006?
Provide a short and direct response. 0.31. What is the ratio of the Number of refugees in Costa Rica in 2003 to that in 2006?
Keep it short and to the point. 0.32. What is the ratio of the Number of refugees of Guinea in 2003 to that in 2006?
Your answer should be very brief. 0.57. What is the ratio of the Number of refugees in Malaysia in 2003 to that in 2006?
Offer a very short reply. 0.41. What is the ratio of the Number of refugees in North America in 2004 to that in 2005?
Give a very brief answer. 0.63. What is the ratio of the Number of refugees of Costa Rica in 2004 to that in 2005?
Ensure brevity in your answer.  0.78. What is the ratio of the Number of refugees of Guinea in 2004 to that in 2005?
Offer a very short reply. 0.82. What is the ratio of the Number of refugees of Malaysia in 2004 to that in 2005?
Your answer should be compact. 0.74. What is the ratio of the Number of refugees in North America in 2004 to that in 2006?
Provide a short and direct response. 0.35. What is the ratio of the Number of refugees of Costa Rica in 2004 to that in 2006?
Your response must be concise. 0.49. What is the ratio of the Number of refugees in Guinea in 2004 to that in 2006?
Provide a succinct answer. 0.7. What is the ratio of the Number of refugees of Malaysia in 2004 to that in 2006?
Give a very brief answer. 0.5. What is the ratio of the Number of refugees in North America in 2005 to that in 2006?
Offer a terse response. 0.56. What is the ratio of the Number of refugees of Costa Rica in 2005 to that in 2006?
Provide a short and direct response. 0.63. What is the ratio of the Number of refugees of Guinea in 2005 to that in 2006?
Ensure brevity in your answer.  0.85. What is the ratio of the Number of refugees in Malaysia in 2005 to that in 2006?
Your answer should be very brief. 0.67. What is the difference between the highest and the second highest Number of refugees of North America?
Ensure brevity in your answer.  644. What is the difference between the highest and the second highest Number of refugees of Costa Rica?
Your response must be concise. 106. What is the difference between the highest and the second highest Number of refugees in Guinea?
Provide a succinct answer. 1020. What is the difference between the highest and the second highest Number of refugees of Malaysia?
Make the answer very short. 190. What is the difference between the highest and the lowest Number of refugees of North America?
Ensure brevity in your answer.  1391. What is the difference between the highest and the lowest Number of refugees of Costa Rica?
Keep it short and to the point. 227. What is the difference between the highest and the lowest Number of refugees of Guinea?
Give a very brief answer. 5689. What is the difference between the highest and the lowest Number of refugees of Malaysia?
Make the answer very short. 505. 